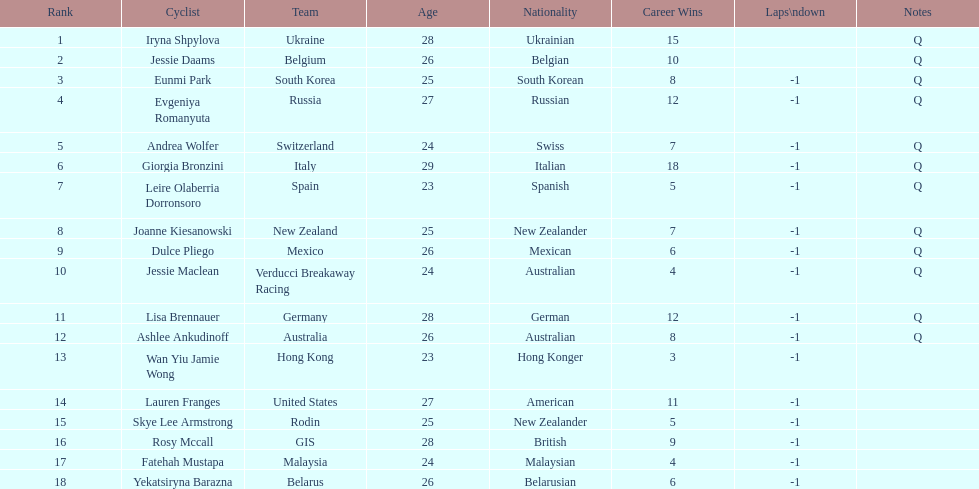Who is the last cyclist listed? Yekatsiryna Barazna. 